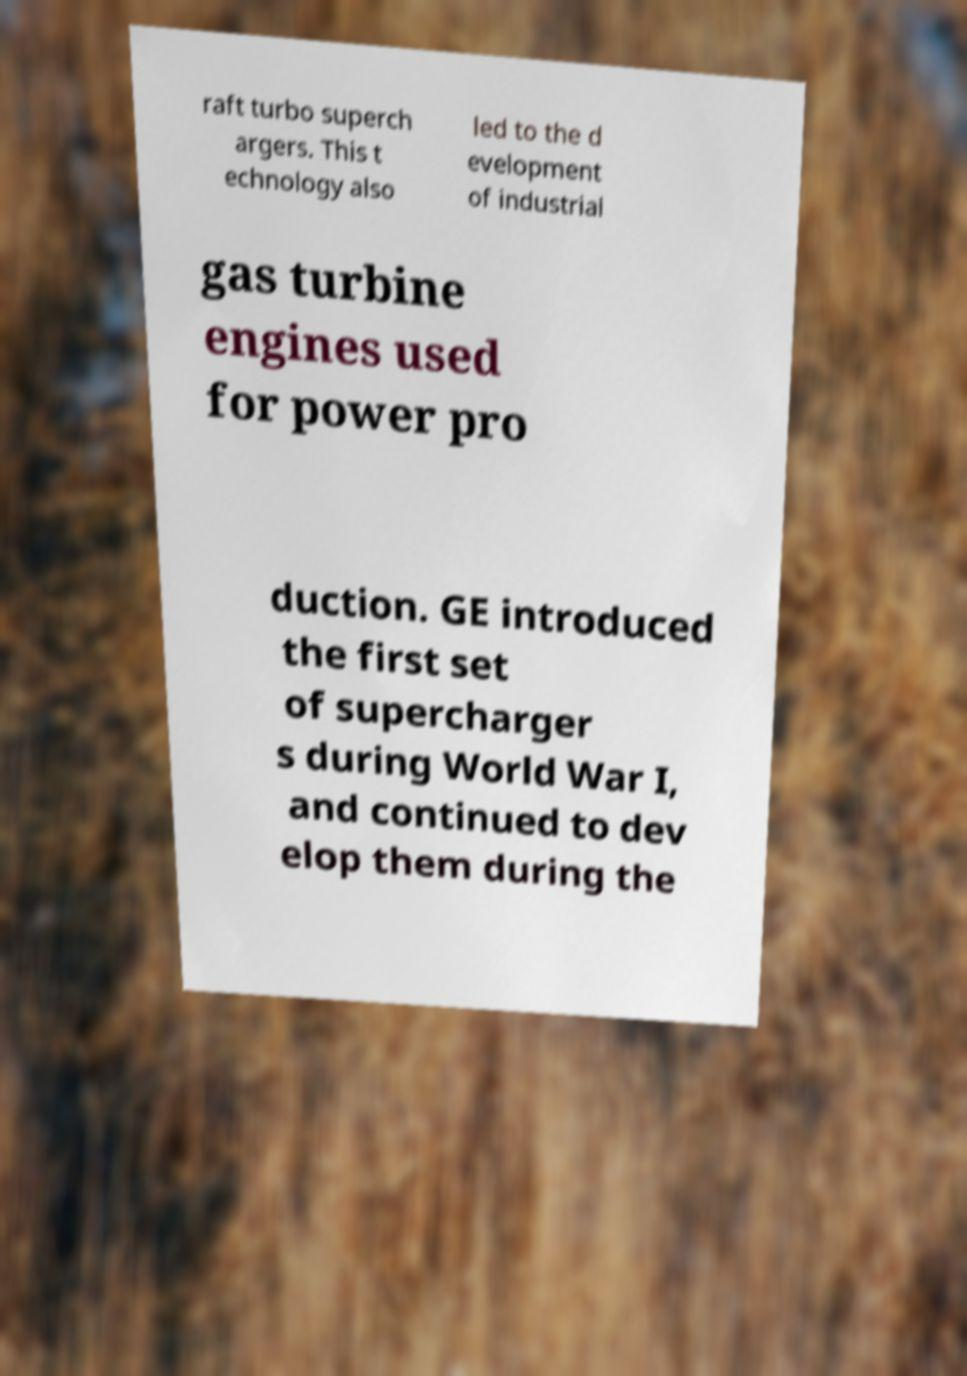For documentation purposes, I need the text within this image transcribed. Could you provide that? raft turbo superch argers. This t echnology also led to the d evelopment of industrial gas turbine engines used for power pro duction. GE introduced the first set of supercharger s during World War I, and continued to dev elop them during the 